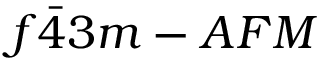<formula> <loc_0><loc_0><loc_500><loc_500>f \bar { 4 } 3 m - A F M</formula> 